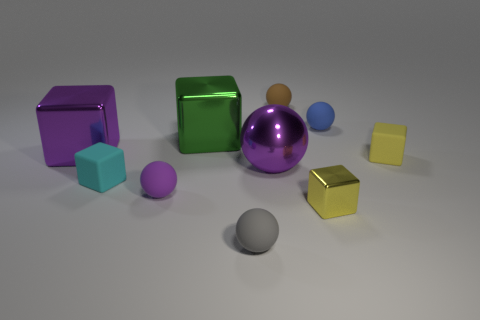Subtract 2 balls. How many balls are left? 3 Subtract all red cubes. Subtract all cyan cylinders. How many cubes are left? 5 Add 6 cyan matte cubes. How many cyan matte cubes exist? 7 Subtract 1 cyan cubes. How many objects are left? 9 Subtract all yellow metal blocks. Subtract all tiny yellow metal things. How many objects are left? 8 Add 3 yellow metal cubes. How many yellow metal cubes are left? 4 